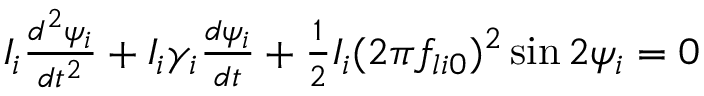Convert formula to latex. <formula><loc_0><loc_0><loc_500><loc_500>\begin{array} { r } { I _ { i } \frac { d ^ { 2 } \psi _ { i } } { d t ^ { 2 } } + I _ { i } \gamma _ { i } \frac { d \psi _ { i } } { d t } + \frac { 1 } { 2 } I _ { i } ( 2 \pi f _ { l i 0 } ) ^ { 2 } \sin 2 \psi _ { i } = 0 } \end{array}</formula> 